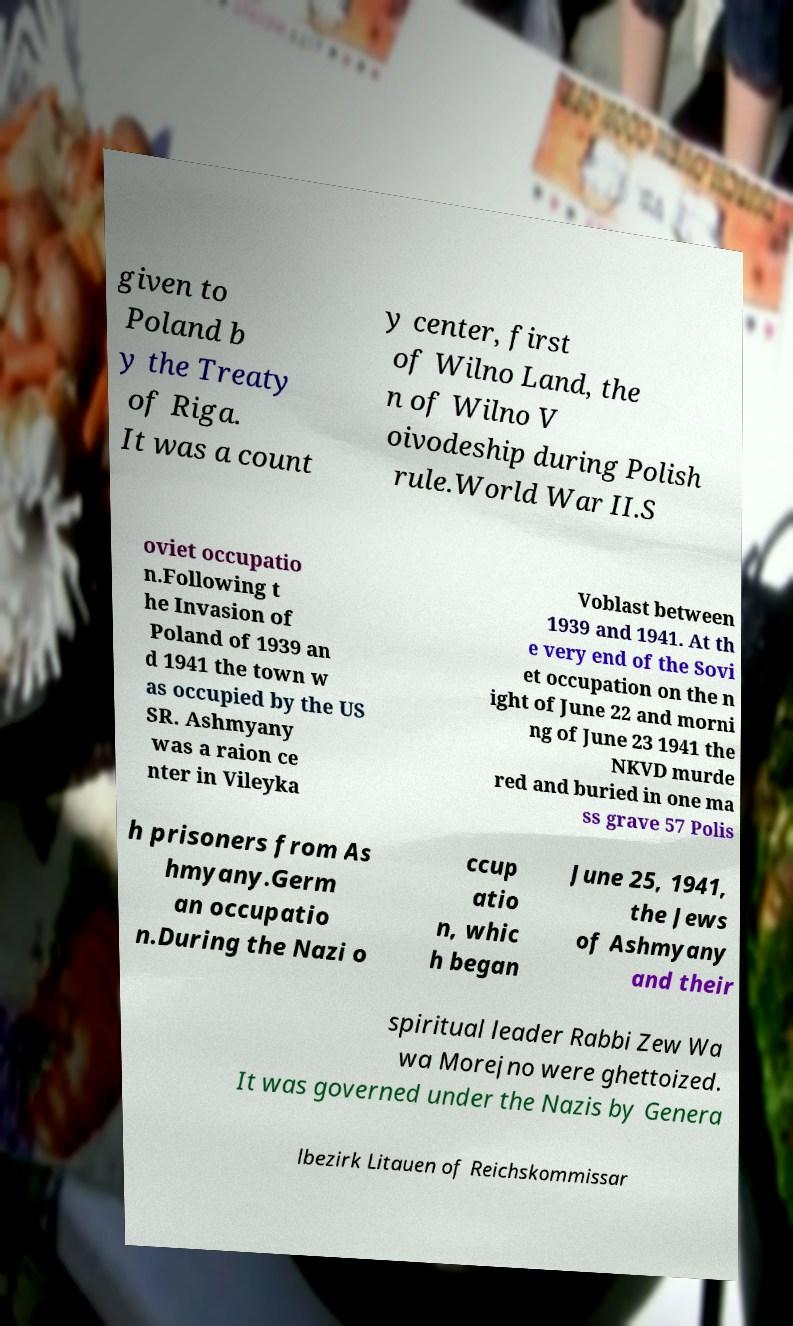Could you extract and type out the text from this image? given to Poland b y the Treaty of Riga. It was a count y center, first of Wilno Land, the n of Wilno V oivodeship during Polish rule.World War II.S oviet occupatio n.Following t he Invasion of Poland of 1939 an d 1941 the town w as occupied by the US SR. Ashmyany was a raion ce nter in Vileyka Voblast between 1939 and 1941. At th e very end of the Sovi et occupation on the n ight of June 22 and morni ng of June 23 1941 the NKVD murde red and buried in one ma ss grave 57 Polis h prisoners from As hmyany.Germ an occupatio n.During the Nazi o ccup atio n, whic h began June 25, 1941, the Jews of Ashmyany and their spiritual leader Rabbi Zew Wa wa Morejno were ghettoized. It was governed under the Nazis by Genera lbezirk Litauen of Reichskommissar 